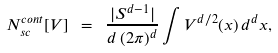Convert formula to latex. <formula><loc_0><loc_0><loc_500><loc_500>N _ { s c } ^ { c o n t } [ V ] \ = \ \frac { | S ^ { d - 1 } | } { d \, ( 2 \pi ) ^ { d } } \int V ^ { d / 2 } ( x ) \, d ^ { d } x ,</formula> 